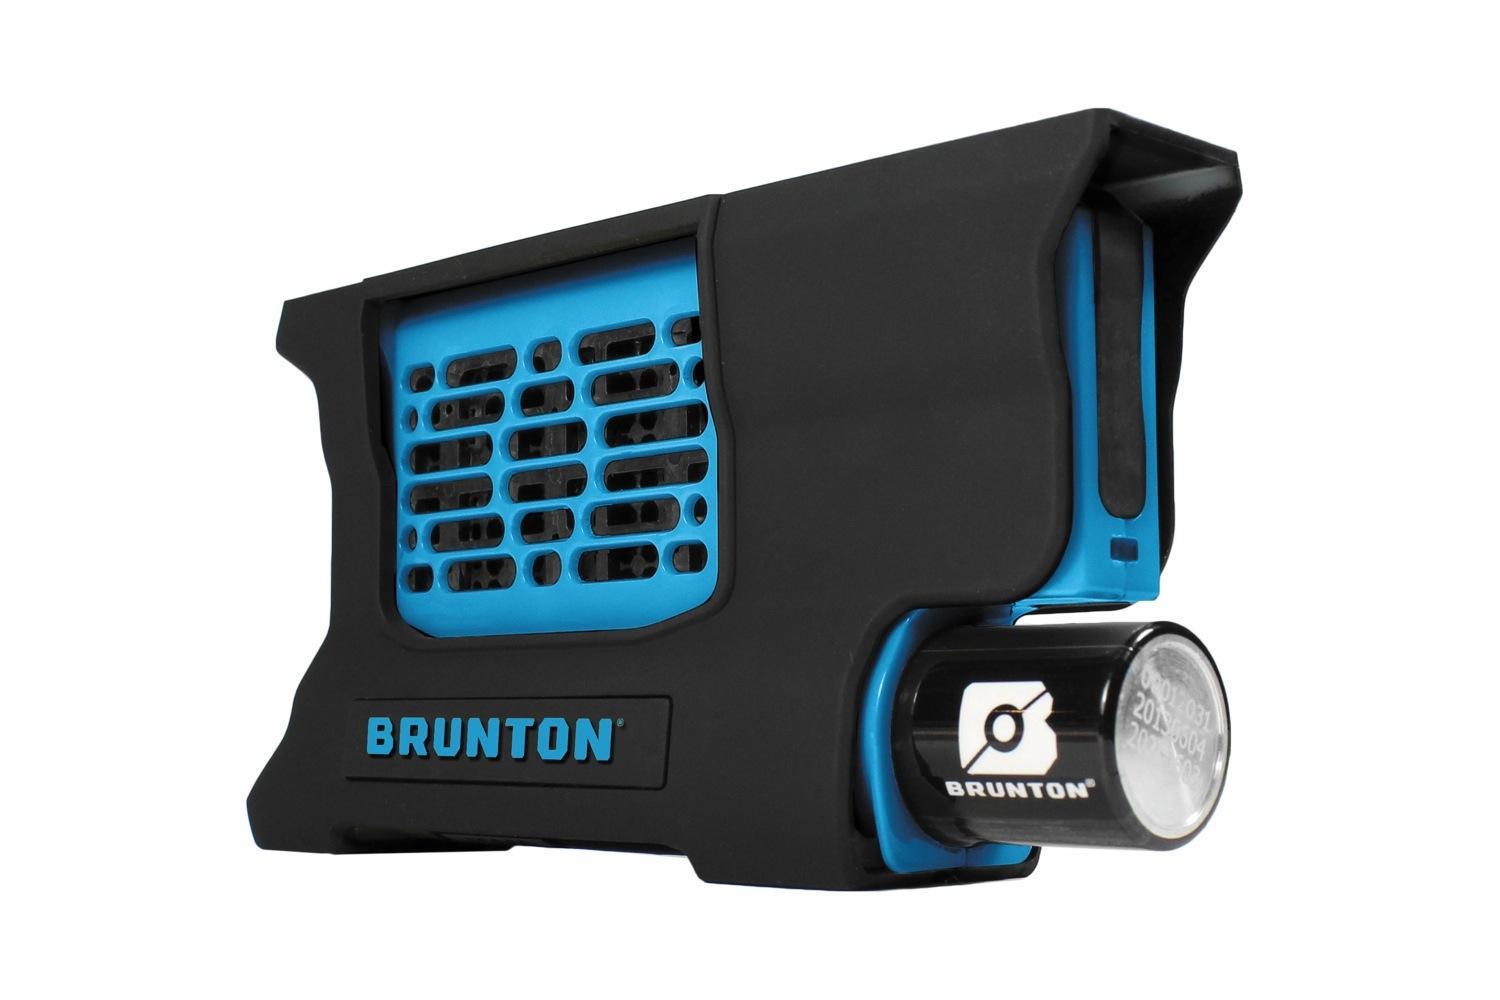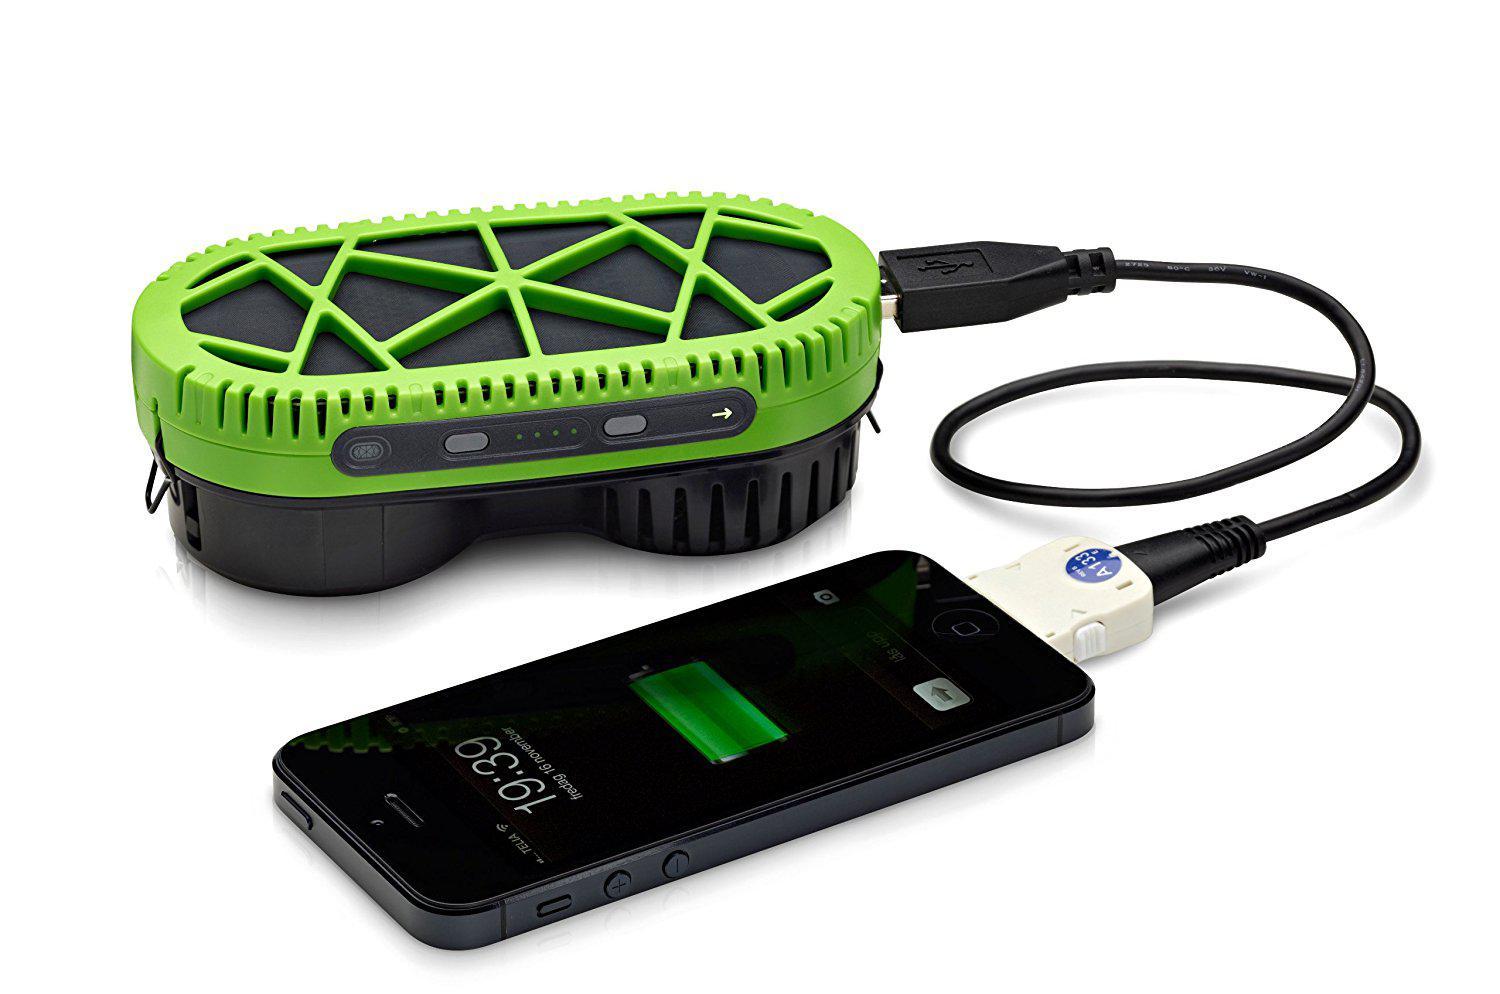The first image is the image on the left, the second image is the image on the right. Assess this claim about the two images: "The right image shows a flat rectangular device with a cord in it, next to a charging device with the other end of the cord in it.". Correct or not? Answer yes or no. Yes. The first image is the image on the left, the second image is the image on the right. Evaluate the accuracy of this statement regarding the images: "There are three devices.". Is it true? Answer yes or no. Yes. 